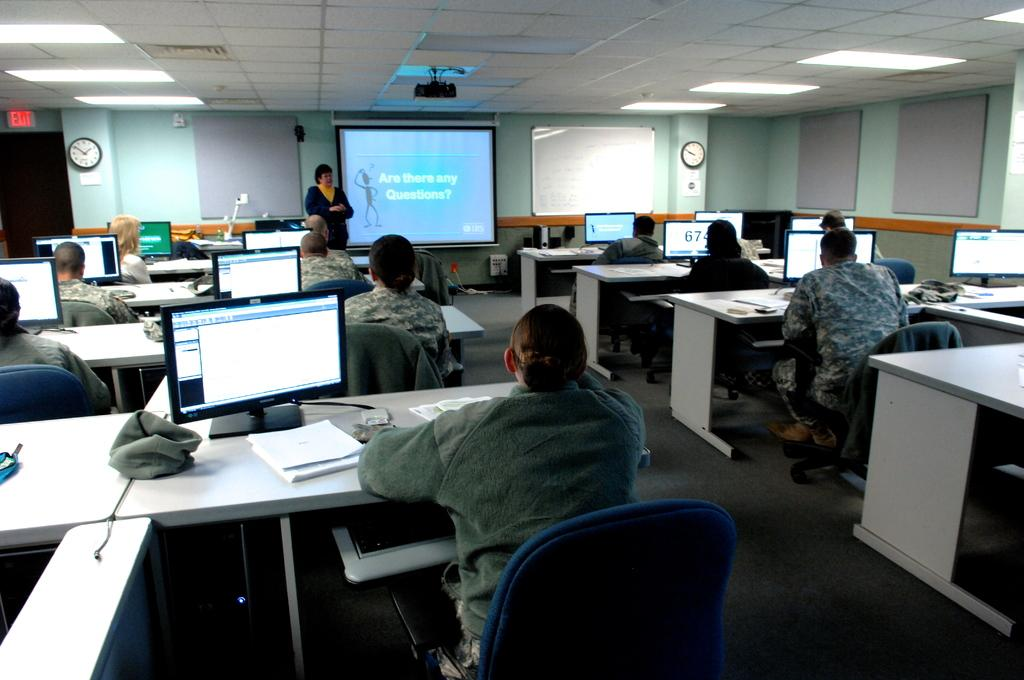<image>
Create a compact narrative representing the image presented. A woman is ready to take questions at the office meeting. 